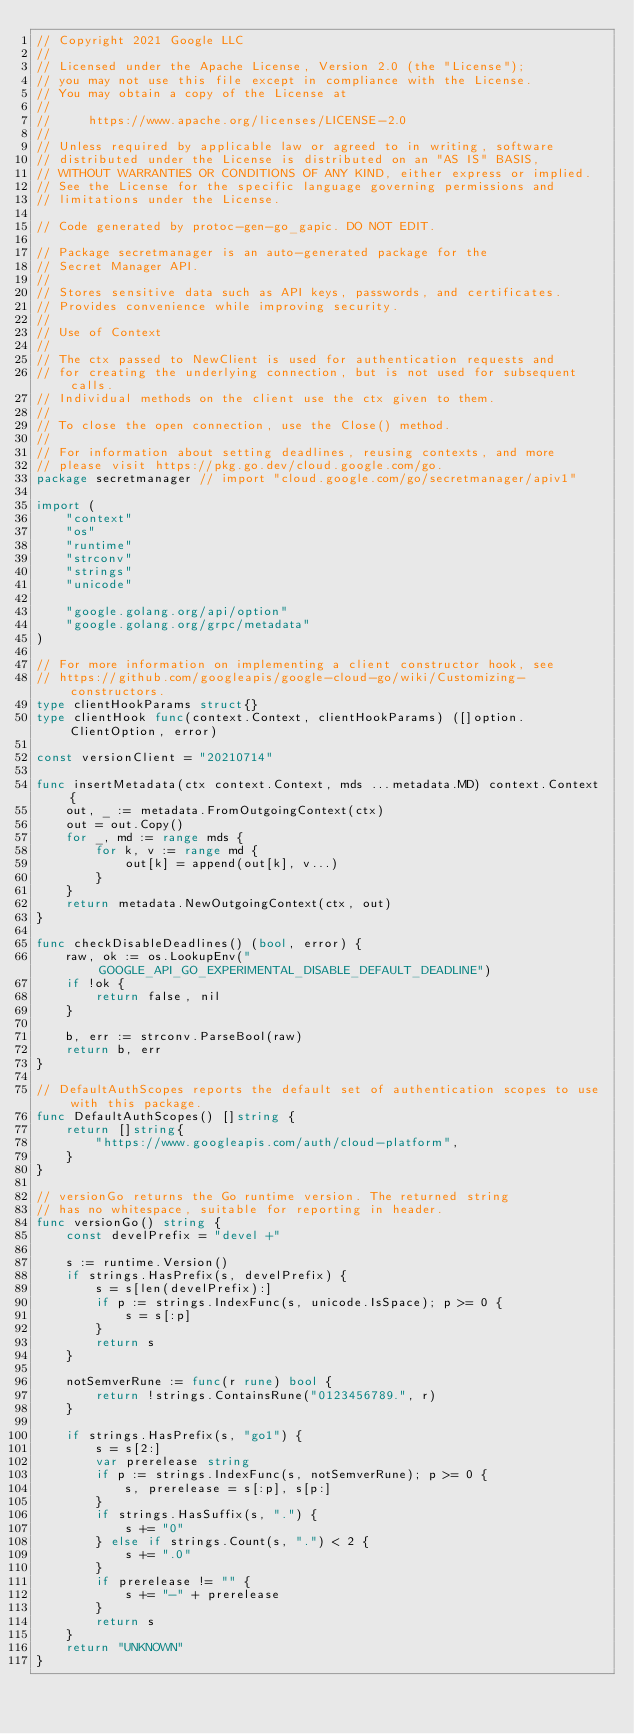<code> <loc_0><loc_0><loc_500><loc_500><_Go_>// Copyright 2021 Google LLC
//
// Licensed under the Apache License, Version 2.0 (the "License");
// you may not use this file except in compliance with the License.
// You may obtain a copy of the License at
//
//     https://www.apache.org/licenses/LICENSE-2.0
//
// Unless required by applicable law or agreed to in writing, software
// distributed under the License is distributed on an "AS IS" BASIS,
// WITHOUT WARRANTIES OR CONDITIONS OF ANY KIND, either express or implied.
// See the License for the specific language governing permissions and
// limitations under the License.

// Code generated by protoc-gen-go_gapic. DO NOT EDIT.

// Package secretmanager is an auto-generated package for the
// Secret Manager API.
//
// Stores sensitive data such as API keys, passwords, and certificates.
// Provides convenience while improving security.
//
// Use of Context
//
// The ctx passed to NewClient is used for authentication requests and
// for creating the underlying connection, but is not used for subsequent calls.
// Individual methods on the client use the ctx given to them.
//
// To close the open connection, use the Close() method.
//
// For information about setting deadlines, reusing contexts, and more
// please visit https://pkg.go.dev/cloud.google.com/go.
package secretmanager // import "cloud.google.com/go/secretmanager/apiv1"

import (
	"context"
	"os"
	"runtime"
	"strconv"
	"strings"
	"unicode"

	"google.golang.org/api/option"
	"google.golang.org/grpc/metadata"
)

// For more information on implementing a client constructor hook, see
// https://github.com/googleapis/google-cloud-go/wiki/Customizing-constructors.
type clientHookParams struct{}
type clientHook func(context.Context, clientHookParams) ([]option.ClientOption, error)

const versionClient = "20210714"

func insertMetadata(ctx context.Context, mds ...metadata.MD) context.Context {
	out, _ := metadata.FromOutgoingContext(ctx)
	out = out.Copy()
	for _, md := range mds {
		for k, v := range md {
			out[k] = append(out[k], v...)
		}
	}
	return metadata.NewOutgoingContext(ctx, out)
}

func checkDisableDeadlines() (bool, error) {
	raw, ok := os.LookupEnv("GOOGLE_API_GO_EXPERIMENTAL_DISABLE_DEFAULT_DEADLINE")
	if !ok {
		return false, nil
	}

	b, err := strconv.ParseBool(raw)
	return b, err
}

// DefaultAuthScopes reports the default set of authentication scopes to use with this package.
func DefaultAuthScopes() []string {
	return []string{
		"https://www.googleapis.com/auth/cloud-platform",
	}
}

// versionGo returns the Go runtime version. The returned string
// has no whitespace, suitable for reporting in header.
func versionGo() string {
	const develPrefix = "devel +"

	s := runtime.Version()
	if strings.HasPrefix(s, develPrefix) {
		s = s[len(develPrefix):]
		if p := strings.IndexFunc(s, unicode.IsSpace); p >= 0 {
			s = s[:p]
		}
		return s
	}

	notSemverRune := func(r rune) bool {
		return !strings.ContainsRune("0123456789.", r)
	}

	if strings.HasPrefix(s, "go1") {
		s = s[2:]
		var prerelease string
		if p := strings.IndexFunc(s, notSemverRune); p >= 0 {
			s, prerelease = s[:p], s[p:]
		}
		if strings.HasSuffix(s, ".") {
			s += "0"
		} else if strings.Count(s, ".") < 2 {
			s += ".0"
		}
		if prerelease != "" {
			s += "-" + prerelease
		}
		return s
	}
	return "UNKNOWN"
}
</code> 